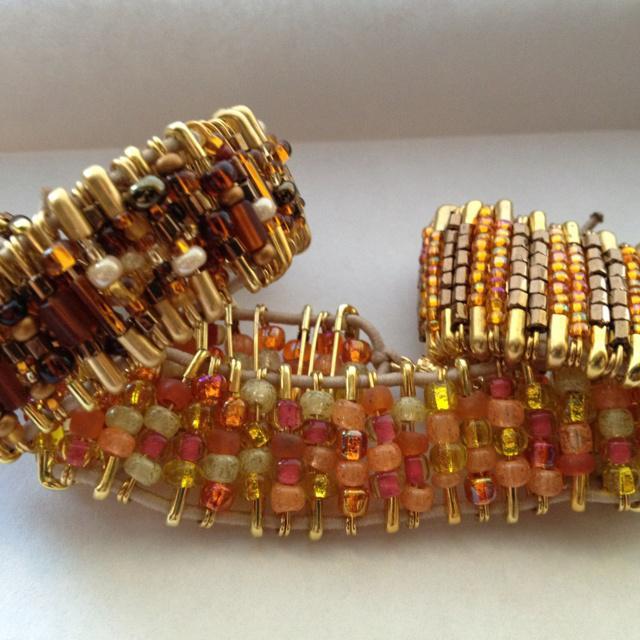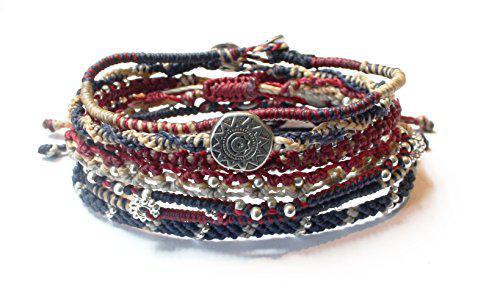The first image is the image on the left, the second image is the image on the right. Assess this claim about the two images: "In the left image, all beads are tans, blacks, whites and oranges.". Correct or not? Answer yes or no. Yes. The first image is the image on the left, the second image is the image on the right. Evaluate the accuracy of this statement regarding the images: "Each image contains one bracelet constructed of rows of vertical beaded safety pins, and no bracelet has a watch face.". Is it true? Answer yes or no. No. 